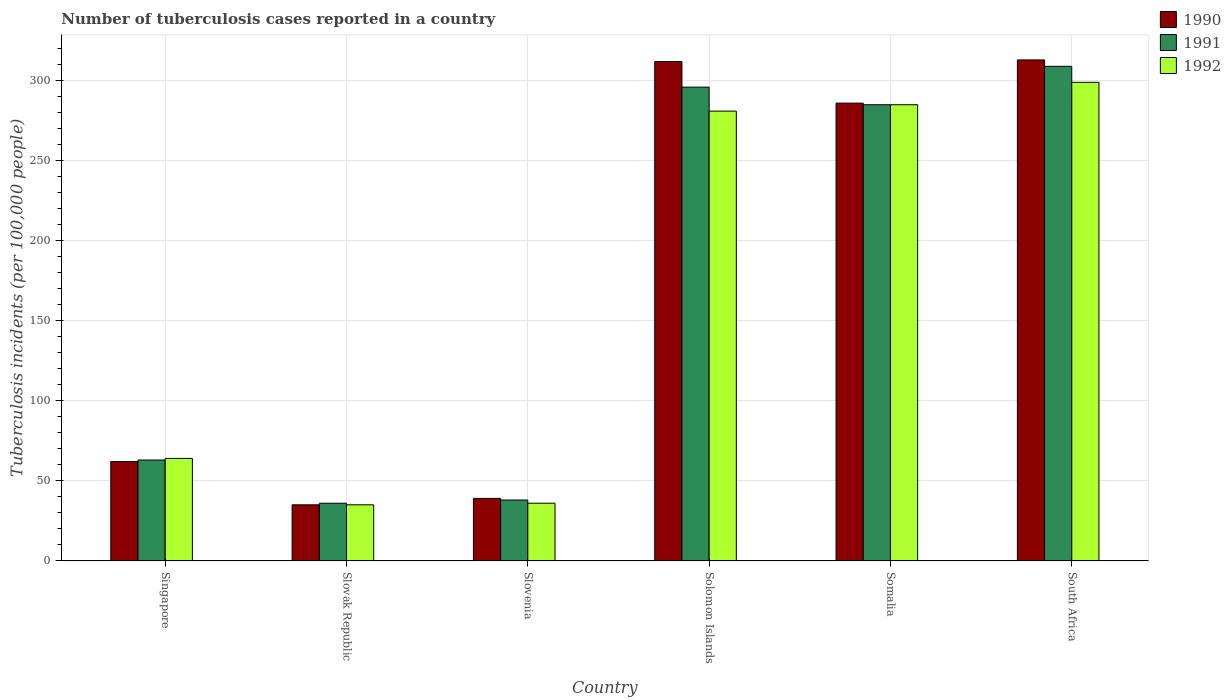How many different coloured bars are there?
Provide a succinct answer. 3. Are the number of bars per tick equal to the number of legend labels?
Your response must be concise. Yes. How many bars are there on the 5th tick from the right?
Offer a terse response. 3. What is the label of the 1st group of bars from the left?
Your answer should be very brief. Singapore. What is the number of tuberculosis cases reported in in 1990 in Slovenia?
Ensure brevity in your answer.  39. Across all countries, what is the maximum number of tuberculosis cases reported in in 1990?
Your answer should be very brief. 313. Across all countries, what is the minimum number of tuberculosis cases reported in in 1992?
Keep it short and to the point. 35. In which country was the number of tuberculosis cases reported in in 1990 maximum?
Provide a short and direct response. South Africa. In which country was the number of tuberculosis cases reported in in 1991 minimum?
Ensure brevity in your answer.  Slovak Republic. What is the total number of tuberculosis cases reported in in 1991 in the graph?
Offer a very short reply. 1027. What is the difference between the number of tuberculosis cases reported in in 1991 in Slovak Republic and that in South Africa?
Your response must be concise. -273. What is the difference between the number of tuberculosis cases reported in in 1991 in Solomon Islands and the number of tuberculosis cases reported in in 1992 in Somalia?
Offer a very short reply. 11. What is the average number of tuberculosis cases reported in in 1991 per country?
Your answer should be compact. 171.17. In how many countries, is the number of tuberculosis cases reported in in 1992 greater than 110?
Give a very brief answer. 3. What is the ratio of the number of tuberculosis cases reported in in 1991 in Slovak Republic to that in Somalia?
Your response must be concise. 0.13. Is the number of tuberculosis cases reported in in 1992 in Somalia less than that in South Africa?
Your answer should be very brief. Yes. What is the difference between the highest and the second highest number of tuberculosis cases reported in in 1991?
Make the answer very short. 11. What is the difference between the highest and the lowest number of tuberculosis cases reported in in 1991?
Your response must be concise. 273. Is the sum of the number of tuberculosis cases reported in in 1990 in Slovak Republic and Solomon Islands greater than the maximum number of tuberculosis cases reported in in 1991 across all countries?
Keep it short and to the point. Yes. Is it the case that in every country, the sum of the number of tuberculosis cases reported in in 1991 and number of tuberculosis cases reported in in 1990 is greater than the number of tuberculosis cases reported in in 1992?
Offer a terse response. Yes. How many countries are there in the graph?
Make the answer very short. 6. What is the difference between two consecutive major ticks on the Y-axis?
Your answer should be compact. 50. Are the values on the major ticks of Y-axis written in scientific E-notation?
Keep it short and to the point. No. Does the graph contain grids?
Offer a terse response. Yes. How many legend labels are there?
Keep it short and to the point. 3. How are the legend labels stacked?
Make the answer very short. Vertical. What is the title of the graph?
Give a very brief answer. Number of tuberculosis cases reported in a country. What is the label or title of the X-axis?
Keep it short and to the point. Country. What is the label or title of the Y-axis?
Your answer should be compact. Tuberculosis incidents (per 100,0 people). What is the Tuberculosis incidents (per 100,000 people) of 1990 in Singapore?
Keep it short and to the point. 62. What is the Tuberculosis incidents (per 100,000 people) in 1991 in Slovak Republic?
Ensure brevity in your answer.  36. What is the Tuberculosis incidents (per 100,000 people) in 1992 in Slovak Republic?
Your response must be concise. 35. What is the Tuberculosis incidents (per 100,000 people) in 1990 in Solomon Islands?
Offer a very short reply. 312. What is the Tuberculosis incidents (per 100,000 people) of 1991 in Solomon Islands?
Offer a terse response. 296. What is the Tuberculosis incidents (per 100,000 people) in 1992 in Solomon Islands?
Your answer should be very brief. 281. What is the Tuberculosis incidents (per 100,000 people) of 1990 in Somalia?
Provide a succinct answer. 286. What is the Tuberculosis incidents (per 100,000 people) of 1991 in Somalia?
Ensure brevity in your answer.  285. What is the Tuberculosis incidents (per 100,000 people) of 1992 in Somalia?
Provide a succinct answer. 285. What is the Tuberculosis incidents (per 100,000 people) of 1990 in South Africa?
Offer a very short reply. 313. What is the Tuberculosis incidents (per 100,000 people) in 1991 in South Africa?
Your response must be concise. 309. What is the Tuberculosis incidents (per 100,000 people) in 1992 in South Africa?
Provide a short and direct response. 299. Across all countries, what is the maximum Tuberculosis incidents (per 100,000 people) in 1990?
Ensure brevity in your answer.  313. Across all countries, what is the maximum Tuberculosis incidents (per 100,000 people) in 1991?
Offer a terse response. 309. Across all countries, what is the maximum Tuberculosis incidents (per 100,000 people) in 1992?
Provide a short and direct response. 299. Across all countries, what is the minimum Tuberculosis incidents (per 100,000 people) in 1990?
Give a very brief answer. 35. Across all countries, what is the minimum Tuberculosis incidents (per 100,000 people) of 1991?
Make the answer very short. 36. What is the total Tuberculosis incidents (per 100,000 people) in 1990 in the graph?
Your response must be concise. 1047. What is the total Tuberculosis incidents (per 100,000 people) in 1991 in the graph?
Keep it short and to the point. 1027. What is the difference between the Tuberculosis incidents (per 100,000 people) of 1991 in Singapore and that in Slovak Republic?
Keep it short and to the point. 27. What is the difference between the Tuberculosis incidents (per 100,000 people) in 1992 in Singapore and that in Slovenia?
Make the answer very short. 28. What is the difference between the Tuberculosis incidents (per 100,000 people) in 1990 in Singapore and that in Solomon Islands?
Ensure brevity in your answer.  -250. What is the difference between the Tuberculosis incidents (per 100,000 people) in 1991 in Singapore and that in Solomon Islands?
Your response must be concise. -233. What is the difference between the Tuberculosis incidents (per 100,000 people) in 1992 in Singapore and that in Solomon Islands?
Your answer should be very brief. -217. What is the difference between the Tuberculosis incidents (per 100,000 people) in 1990 in Singapore and that in Somalia?
Your answer should be very brief. -224. What is the difference between the Tuberculosis incidents (per 100,000 people) in 1991 in Singapore and that in Somalia?
Your answer should be very brief. -222. What is the difference between the Tuberculosis incidents (per 100,000 people) of 1992 in Singapore and that in Somalia?
Ensure brevity in your answer.  -221. What is the difference between the Tuberculosis incidents (per 100,000 people) in 1990 in Singapore and that in South Africa?
Provide a succinct answer. -251. What is the difference between the Tuberculosis incidents (per 100,000 people) of 1991 in Singapore and that in South Africa?
Offer a terse response. -246. What is the difference between the Tuberculosis incidents (per 100,000 people) of 1992 in Singapore and that in South Africa?
Provide a short and direct response. -235. What is the difference between the Tuberculosis incidents (per 100,000 people) in 1991 in Slovak Republic and that in Slovenia?
Make the answer very short. -2. What is the difference between the Tuberculosis incidents (per 100,000 people) of 1992 in Slovak Republic and that in Slovenia?
Your response must be concise. -1. What is the difference between the Tuberculosis incidents (per 100,000 people) in 1990 in Slovak Republic and that in Solomon Islands?
Make the answer very short. -277. What is the difference between the Tuberculosis incidents (per 100,000 people) in 1991 in Slovak Republic and that in Solomon Islands?
Provide a succinct answer. -260. What is the difference between the Tuberculosis incidents (per 100,000 people) in 1992 in Slovak Republic and that in Solomon Islands?
Provide a succinct answer. -246. What is the difference between the Tuberculosis incidents (per 100,000 people) of 1990 in Slovak Republic and that in Somalia?
Keep it short and to the point. -251. What is the difference between the Tuberculosis incidents (per 100,000 people) of 1991 in Slovak Republic and that in Somalia?
Provide a short and direct response. -249. What is the difference between the Tuberculosis incidents (per 100,000 people) in 1992 in Slovak Republic and that in Somalia?
Offer a terse response. -250. What is the difference between the Tuberculosis incidents (per 100,000 people) of 1990 in Slovak Republic and that in South Africa?
Your answer should be very brief. -278. What is the difference between the Tuberculosis incidents (per 100,000 people) of 1991 in Slovak Republic and that in South Africa?
Provide a succinct answer. -273. What is the difference between the Tuberculosis incidents (per 100,000 people) of 1992 in Slovak Republic and that in South Africa?
Make the answer very short. -264. What is the difference between the Tuberculosis incidents (per 100,000 people) of 1990 in Slovenia and that in Solomon Islands?
Give a very brief answer. -273. What is the difference between the Tuberculosis incidents (per 100,000 people) of 1991 in Slovenia and that in Solomon Islands?
Provide a succinct answer. -258. What is the difference between the Tuberculosis incidents (per 100,000 people) of 1992 in Slovenia and that in Solomon Islands?
Provide a short and direct response. -245. What is the difference between the Tuberculosis incidents (per 100,000 people) of 1990 in Slovenia and that in Somalia?
Your answer should be compact. -247. What is the difference between the Tuberculosis incidents (per 100,000 people) in 1991 in Slovenia and that in Somalia?
Make the answer very short. -247. What is the difference between the Tuberculosis incidents (per 100,000 people) of 1992 in Slovenia and that in Somalia?
Your answer should be compact. -249. What is the difference between the Tuberculosis incidents (per 100,000 people) of 1990 in Slovenia and that in South Africa?
Offer a terse response. -274. What is the difference between the Tuberculosis incidents (per 100,000 people) of 1991 in Slovenia and that in South Africa?
Provide a short and direct response. -271. What is the difference between the Tuberculosis incidents (per 100,000 people) of 1992 in Slovenia and that in South Africa?
Provide a succinct answer. -263. What is the difference between the Tuberculosis incidents (per 100,000 people) in 1991 in Solomon Islands and that in Somalia?
Offer a terse response. 11. What is the difference between the Tuberculosis incidents (per 100,000 people) of 1991 in Solomon Islands and that in South Africa?
Give a very brief answer. -13. What is the difference between the Tuberculosis incidents (per 100,000 people) of 1992 in Solomon Islands and that in South Africa?
Offer a very short reply. -18. What is the difference between the Tuberculosis incidents (per 100,000 people) in 1991 in Singapore and the Tuberculosis incidents (per 100,000 people) in 1992 in Slovak Republic?
Your answer should be compact. 28. What is the difference between the Tuberculosis incidents (per 100,000 people) in 1991 in Singapore and the Tuberculosis incidents (per 100,000 people) in 1992 in Slovenia?
Keep it short and to the point. 27. What is the difference between the Tuberculosis incidents (per 100,000 people) of 1990 in Singapore and the Tuberculosis incidents (per 100,000 people) of 1991 in Solomon Islands?
Offer a very short reply. -234. What is the difference between the Tuberculosis incidents (per 100,000 people) in 1990 in Singapore and the Tuberculosis incidents (per 100,000 people) in 1992 in Solomon Islands?
Provide a short and direct response. -219. What is the difference between the Tuberculosis incidents (per 100,000 people) of 1991 in Singapore and the Tuberculosis incidents (per 100,000 people) of 1992 in Solomon Islands?
Your answer should be very brief. -218. What is the difference between the Tuberculosis incidents (per 100,000 people) in 1990 in Singapore and the Tuberculosis incidents (per 100,000 people) in 1991 in Somalia?
Provide a succinct answer. -223. What is the difference between the Tuberculosis incidents (per 100,000 people) of 1990 in Singapore and the Tuberculosis incidents (per 100,000 people) of 1992 in Somalia?
Offer a very short reply. -223. What is the difference between the Tuberculosis incidents (per 100,000 people) in 1991 in Singapore and the Tuberculosis incidents (per 100,000 people) in 1992 in Somalia?
Offer a terse response. -222. What is the difference between the Tuberculosis incidents (per 100,000 people) in 1990 in Singapore and the Tuberculosis incidents (per 100,000 people) in 1991 in South Africa?
Your answer should be compact. -247. What is the difference between the Tuberculosis incidents (per 100,000 people) of 1990 in Singapore and the Tuberculosis incidents (per 100,000 people) of 1992 in South Africa?
Ensure brevity in your answer.  -237. What is the difference between the Tuberculosis incidents (per 100,000 people) in 1991 in Singapore and the Tuberculosis incidents (per 100,000 people) in 1992 in South Africa?
Provide a short and direct response. -236. What is the difference between the Tuberculosis incidents (per 100,000 people) of 1990 in Slovak Republic and the Tuberculosis incidents (per 100,000 people) of 1991 in Slovenia?
Give a very brief answer. -3. What is the difference between the Tuberculosis incidents (per 100,000 people) of 1991 in Slovak Republic and the Tuberculosis incidents (per 100,000 people) of 1992 in Slovenia?
Provide a succinct answer. 0. What is the difference between the Tuberculosis incidents (per 100,000 people) of 1990 in Slovak Republic and the Tuberculosis incidents (per 100,000 people) of 1991 in Solomon Islands?
Keep it short and to the point. -261. What is the difference between the Tuberculosis incidents (per 100,000 people) of 1990 in Slovak Republic and the Tuberculosis incidents (per 100,000 people) of 1992 in Solomon Islands?
Ensure brevity in your answer.  -246. What is the difference between the Tuberculosis incidents (per 100,000 people) of 1991 in Slovak Republic and the Tuberculosis incidents (per 100,000 people) of 1992 in Solomon Islands?
Make the answer very short. -245. What is the difference between the Tuberculosis incidents (per 100,000 people) of 1990 in Slovak Republic and the Tuberculosis incidents (per 100,000 people) of 1991 in Somalia?
Provide a short and direct response. -250. What is the difference between the Tuberculosis incidents (per 100,000 people) in 1990 in Slovak Republic and the Tuberculosis incidents (per 100,000 people) in 1992 in Somalia?
Provide a short and direct response. -250. What is the difference between the Tuberculosis incidents (per 100,000 people) of 1991 in Slovak Republic and the Tuberculosis incidents (per 100,000 people) of 1992 in Somalia?
Provide a succinct answer. -249. What is the difference between the Tuberculosis incidents (per 100,000 people) in 1990 in Slovak Republic and the Tuberculosis incidents (per 100,000 people) in 1991 in South Africa?
Ensure brevity in your answer.  -274. What is the difference between the Tuberculosis incidents (per 100,000 people) of 1990 in Slovak Republic and the Tuberculosis incidents (per 100,000 people) of 1992 in South Africa?
Make the answer very short. -264. What is the difference between the Tuberculosis incidents (per 100,000 people) of 1991 in Slovak Republic and the Tuberculosis incidents (per 100,000 people) of 1992 in South Africa?
Give a very brief answer. -263. What is the difference between the Tuberculosis incidents (per 100,000 people) of 1990 in Slovenia and the Tuberculosis incidents (per 100,000 people) of 1991 in Solomon Islands?
Give a very brief answer. -257. What is the difference between the Tuberculosis incidents (per 100,000 people) of 1990 in Slovenia and the Tuberculosis incidents (per 100,000 people) of 1992 in Solomon Islands?
Give a very brief answer. -242. What is the difference between the Tuberculosis incidents (per 100,000 people) in 1991 in Slovenia and the Tuberculosis incidents (per 100,000 people) in 1992 in Solomon Islands?
Offer a very short reply. -243. What is the difference between the Tuberculosis incidents (per 100,000 people) in 1990 in Slovenia and the Tuberculosis incidents (per 100,000 people) in 1991 in Somalia?
Provide a succinct answer. -246. What is the difference between the Tuberculosis incidents (per 100,000 people) of 1990 in Slovenia and the Tuberculosis incidents (per 100,000 people) of 1992 in Somalia?
Your response must be concise. -246. What is the difference between the Tuberculosis incidents (per 100,000 people) in 1991 in Slovenia and the Tuberculosis incidents (per 100,000 people) in 1992 in Somalia?
Keep it short and to the point. -247. What is the difference between the Tuberculosis incidents (per 100,000 people) in 1990 in Slovenia and the Tuberculosis incidents (per 100,000 people) in 1991 in South Africa?
Keep it short and to the point. -270. What is the difference between the Tuberculosis incidents (per 100,000 people) in 1990 in Slovenia and the Tuberculosis incidents (per 100,000 people) in 1992 in South Africa?
Make the answer very short. -260. What is the difference between the Tuberculosis incidents (per 100,000 people) in 1991 in Slovenia and the Tuberculosis incidents (per 100,000 people) in 1992 in South Africa?
Offer a very short reply. -261. What is the difference between the Tuberculosis incidents (per 100,000 people) of 1990 in Solomon Islands and the Tuberculosis incidents (per 100,000 people) of 1992 in Somalia?
Offer a very short reply. 27. What is the difference between the Tuberculosis incidents (per 100,000 people) of 1991 in Solomon Islands and the Tuberculosis incidents (per 100,000 people) of 1992 in Somalia?
Offer a terse response. 11. What is the difference between the Tuberculosis incidents (per 100,000 people) in 1990 in Solomon Islands and the Tuberculosis incidents (per 100,000 people) in 1991 in South Africa?
Provide a succinct answer. 3. What is the difference between the Tuberculosis incidents (per 100,000 people) in 1990 in Solomon Islands and the Tuberculosis incidents (per 100,000 people) in 1992 in South Africa?
Your answer should be very brief. 13. What is the difference between the Tuberculosis incidents (per 100,000 people) of 1991 in Solomon Islands and the Tuberculosis incidents (per 100,000 people) of 1992 in South Africa?
Make the answer very short. -3. What is the difference between the Tuberculosis incidents (per 100,000 people) of 1990 in Somalia and the Tuberculosis incidents (per 100,000 people) of 1991 in South Africa?
Your answer should be very brief. -23. What is the difference between the Tuberculosis incidents (per 100,000 people) in 1990 in Somalia and the Tuberculosis incidents (per 100,000 people) in 1992 in South Africa?
Offer a very short reply. -13. What is the average Tuberculosis incidents (per 100,000 people) of 1990 per country?
Your answer should be compact. 174.5. What is the average Tuberculosis incidents (per 100,000 people) of 1991 per country?
Offer a terse response. 171.17. What is the average Tuberculosis incidents (per 100,000 people) in 1992 per country?
Your answer should be very brief. 166.67. What is the difference between the Tuberculosis incidents (per 100,000 people) in 1990 and Tuberculosis incidents (per 100,000 people) in 1992 in Singapore?
Your answer should be very brief. -2. What is the difference between the Tuberculosis incidents (per 100,000 people) in 1991 and Tuberculosis incidents (per 100,000 people) in 1992 in Singapore?
Your answer should be very brief. -1. What is the difference between the Tuberculosis incidents (per 100,000 people) in 1991 and Tuberculosis incidents (per 100,000 people) in 1992 in Slovak Republic?
Offer a terse response. 1. What is the difference between the Tuberculosis incidents (per 100,000 people) of 1990 and Tuberculosis incidents (per 100,000 people) of 1992 in Slovenia?
Give a very brief answer. 3. What is the difference between the Tuberculosis incidents (per 100,000 people) of 1990 and Tuberculosis incidents (per 100,000 people) of 1991 in Somalia?
Provide a succinct answer. 1. What is the difference between the Tuberculosis incidents (per 100,000 people) in 1990 and Tuberculosis incidents (per 100,000 people) in 1992 in Somalia?
Your response must be concise. 1. What is the difference between the Tuberculosis incidents (per 100,000 people) of 1991 and Tuberculosis incidents (per 100,000 people) of 1992 in Somalia?
Your answer should be compact. 0. What is the difference between the Tuberculosis incidents (per 100,000 people) of 1990 and Tuberculosis incidents (per 100,000 people) of 1992 in South Africa?
Your answer should be very brief. 14. What is the difference between the Tuberculosis incidents (per 100,000 people) in 1991 and Tuberculosis incidents (per 100,000 people) in 1992 in South Africa?
Provide a succinct answer. 10. What is the ratio of the Tuberculosis incidents (per 100,000 people) of 1990 in Singapore to that in Slovak Republic?
Give a very brief answer. 1.77. What is the ratio of the Tuberculosis incidents (per 100,000 people) of 1991 in Singapore to that in Slovak Republic?
Make the answer very short. 1.75. What is the ratio of the Tuberculosis incidents (per 100,000 people) in 1992 in Singapore to that in Slovak Republic?
Your answer should be compact. 1.83. What is the ratio of the Tuberculosis incidents (per 100,000 people) in 1990 in Singapore to that in Slovenia?
Provide a succinct answer. 1.59. What is the ratio of the Tuberculosis incidents (per 100,000 people) in 1991 in Singapore to that in Slovenia?
Make the answer very short. 1.66. What is the ratio of the Tuberculosis incidents (per 100,000 people) in 1992 in Singapore to that in Slovenia?
Ensure brevity in your answer.  1.78. What is the ratio of the Tuberculosis incidents (per 100,000 people) in 1990 in Singapore to that in Solomon Islands?
Provide a short and direct response. 0.2. What is the ratio of the Tuberculosis incidents (per 100,000 people) of 1991 in Singapore to that in Solomon Islands?
Provide a succinct answer. 0.21. What is the ratio of the Tuberculosis incidents (per 100,000 people) of 1992 in Singapore to that in Solomon Islands?
Your answer should be very brief. 0.23. What is the ratio of the Tuberculosis incidents (per 100,000 people) of 1990 in Singapore to that in Somalia?
Provide a short and direct response. 0.22. What is the ratio of the Tuberculosis incidents (per 100,000 people) in 1991 in Singapore to that in Somalia?
Provide a succinct answer. 0.22. What is the ratio of the Tuberculosis incidents (per 100,000 people) of 1992 in Singapore to that in Somalia?
Ensure brevity in your answer.  0.22. What is the ratio of the Tuberculosis incidents (per 100,000 people) in 1990 in Singapore to that in South Africa?
Ensure brevity in your answer.  0.2. What is the ratio of the Tuberculosis incidents (per 100,000 people) in 1991 in Singapore to that in South Africa?
Give a very brief answer. 0.2. What is the ratio of the Tuberculosis incidents (per 100,000 people) in 1992 in Singapore to that in South Africa?
Make the answer very short. 0.21. What is the ratio of the Tuberculosis incidents (per 100,000 people) in 1990 in Slovak Republic to that in Slovenia?
Your answer should be compact. 0.9. What is the ratio of the Tuberculosis incidents (per 100,000 people) of 1991 in Slovak Republic to that in Slovenia?
Provide a succinct answer. 0.95. What is the ratio of the Tuberculosis incidents (per 100,000 people) in 1992 in Slovak Republic to that in Slovenia?
Give a very brief answer. 0.97. What is the ratio of the Tuberculosis incidents (per 100,000 people) of 1990 in Slovak Republic to that in Solomon Islands?
Offer a terse response. 0.11. What is the ratio of the Tuberculosis incidents (per 100,000 people) in 1991 in Slovak Republic to that in Solomon Islands?
Keep it short and to the point. 0.12. What is the ratio of the Tuberculosis incidents (per 100,000 people) in 1992 in Slovak Republic to that in Solomon Islands?
Make the answer very short. 0.12. What is the ratio of the Tuberculosis incidents (per 100,000 people) of 1990 in Slovak Republic to that in Somalia?
Your answer should be very brief. 0.12. What is the ratio of the Tuberculosis incidents (per 100,000 people) in 1991 in Slovak Republic to that in Somalia?
Keep it short and to the point. 0.13. What is the ratio of the Tuberculosis incidents (per 100,000 people) of 1992 in Slovak Republic to that in Somalia?
Offer a terse response. 0.12. What is the ratio of the Tuberculosis incidents (per 100,000 people) in 1990 in Slovak Republic to that in South Africa?
Offer a terse response. 0.11. What is the ratio of the Tuberculosis incidents (per 100,000 people) in 1991 in Slovak Republic to that in South Africa?
Offer a very short reply. 0.12. What is the ratio of the Tuberculosis incidents (per 100,000 people) in 1992 in Slovak Republic to that in South Africa?
Ensure brevity in your answer.  0.12. What is the ratio of the Tuberculosis incidents (per 100,000 people) in 1990 in Slovenia to that in Solomon Islands?
Your response must be concise. 0.12. What is the ratio of the Tuberculosis incidents (per 100,000 people) in 1991 in Slovenia to that in Solomon Islands?
Give a very brief answer. 0.13. What is the ratio of the Tuberculosis incidents (per 100,000 people) in 1992 in Slovenia to that in Solomon Islands?
Your response must be concise. 0.13. What is the ratio of the Tuberculosis incidents (per 100,000 people) of 1990 in Slovenia to that in Somalia?
Keep it short and to the point. 0.14. What is the ratio of the Tuberculosis incidents (per 100,000 people) of 1991 in Slovenia to that in Somalia?
Offer a very short reply. 0.13. What is the ratio of the Tuberculosis incidents (per 100,000 people) of 1992 in Slovenia to that in Somalia?
Ensure brevity in your answer.  0.13. What is the ratio of the Tuberculosis incidents (per 100,000 people) of 1990 in Slovenia to that in South Africa?
Your response must be concise. 0.12. What is the ratio of the Tuberculosis incidents (per 100,000 people) of 1991 in Slovenia to that in South Africa?
Provide a succinct answer. 0.12. What is the ratio of the Tuberculosis incidents (per 100,000 people) of 1992 in Slovenia to that in South Africa?
Offer a very short reply. 0.12. What is the ratio of the Tuberculosis incidents (per 100,000 people) of 1991 in Solomon Islands to that in Somalia?
Your response must be concise. 1.04. What is the ratio of the Tuberculosis incidents (per 100,000 people) in 1991 in Solomon Islands to that in South Africa?
Offer a very short reply. 0.96. What is the ratio of the Tuberculosis incidents (per 100,000 people) in 1992 in Solomon Islands to that in South Africa?
Offer a very short reply. 0.94. What is the ratio of the Tuberculosis incidents (per 100,000 people) in 1990 in Somalia to that in South Africa?
Offer a terse response. 0.91. What is the ratio of the Tuberculosis incidents (per 100,000 people) of 1991 in Somalia to that in South Africa?
Provide a short and direct response. 0.92. What is the ratio of the Tuberculosis incidents (per 100,000 people) of 1992 in Somalia to that in South Africa?
Make the answer very short. 0.95. What is the difference between the highest and the second highest Tuberculosis incidents (per 100,000 people) of 1991?
Your answer should be very brief. 13. What is the difference between the highest and the second highest Tuberculosis incidents (per 100,000 people) in 1992?
Your response must be concise. 14. What is the difference between the highest and the lowest Tuberculosis incidents (per 100,000 people) of 1990?
Your answer should be very brief. 278. What is the difference between the highest and the lowest Tuberculosis incidents (per 100,000 people) in 1991?
Your answer should be compact. 273. What is the difference between the highest and the lowest Tuberculosis incidents (per 100,000 people) of 1992?
Keep it short and to the point. 264. 